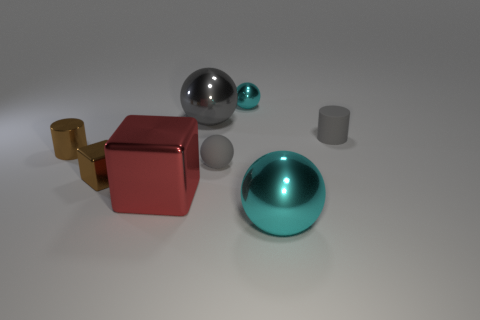Is the number of large cyan shiny balls less than the number of cyan spheres?
Your response must be concise. Yes. Are there any large brown cylinders that have the same material as the tiny brown cylinder?
Your answer should be very brief. No. Does the big cyan object have the same shape as the thing that is behind the big gray metallic thing?
Give a very brief answer. Yes. There is a small gray sphere; are there any cylinders on the left side of it?
Provide a succinct answer. Yes. What number of red objects have the same shape as the large cyan metallic thing?
Make the answer very short. 0. Is the material of the gray cylinder the same as the big sphere that is to the right of the tiny metal sphere?
Ensure brevity in your answer.  No. What number of large purple rubber balls are there?
Your answer should be very brief. 0. There is a cyan thing in front of the gray cylinder; how big is it?
Ensure brevity in your answer.  Large. How many shiny blocks have the same size as the gray metal sphere?
Give a very brief answer. 1. What material is the small thing that is in front of the metal cylinder and behind the tiny shiny cube?
Your response must be concise. Rubber. 